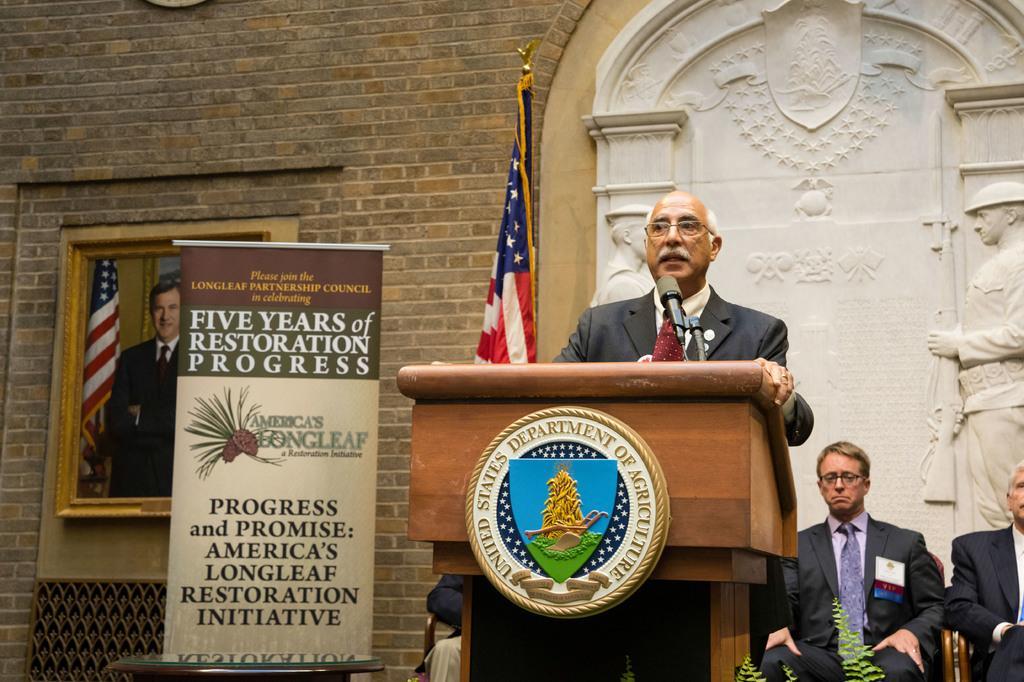Describe this image in one or two sentences. In the image a person is standing beside a podium. On the podium there is a logo. On it there is a mic. The person is speaking something. In the right two persons are sitting on chair. In the left of the podium a person is sitting. In the background there is statue. Here there is a banner. On the wall there is a photo frame of a man wearing black suit. 